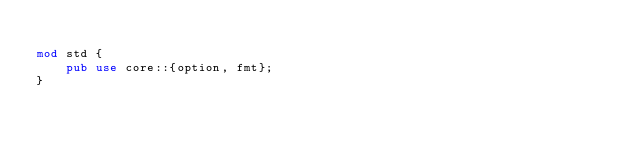Convert code to text. <code><loc_0><loc_0><loc_500><loc_500><_Rust_>
mod std {
    pub use core::{option, fmt};
}
</code> 